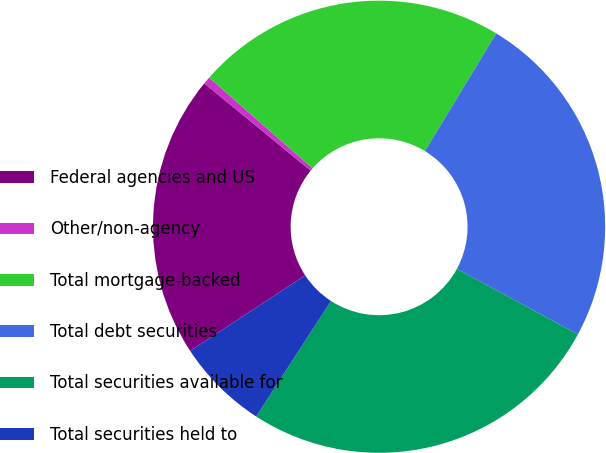Convert chart to OTSL. <chart><loc_0><loc_0><loc_500><loc_500><pie_chart><fcel>Federal agencies and US<fcel>Other/non-agency<fcel>Total mortgage-backed<fcel>Total debt securities<fcel>Total securities available for<fcel>Total securities held to<nl><fcel>20.19%<fcel>0.53%<fcel>22.21%<fcel>24.23%<fcel>26.25%<fcel>6.6%<nl></chart> 